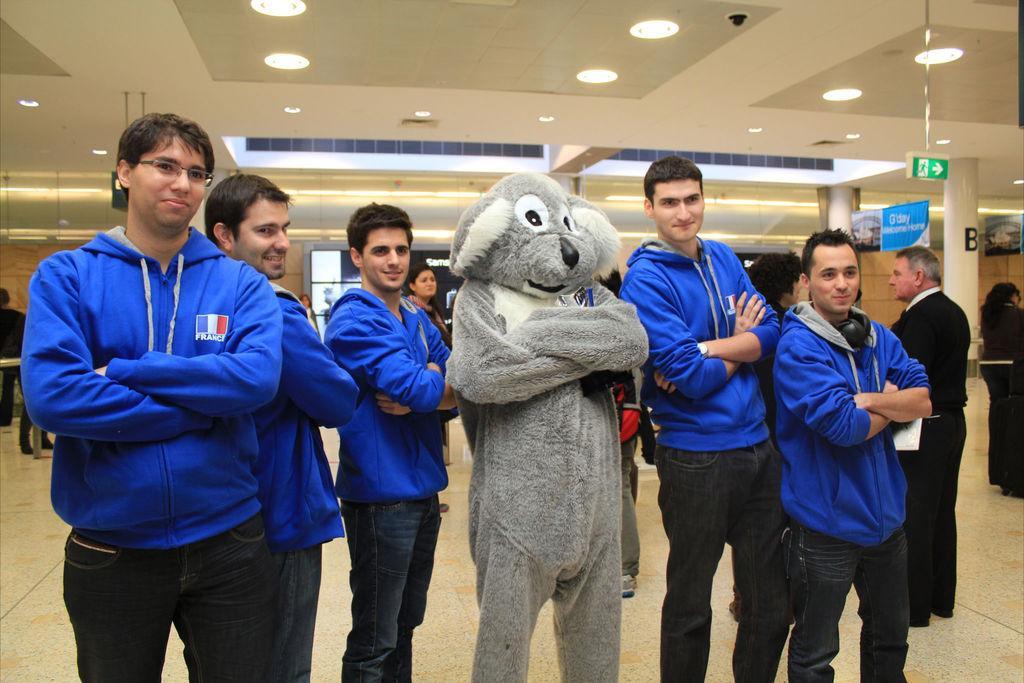Please provide a concise description of this image. Front these people are standing. Background there are people. These are lights. Here we can see banners, pillars and signboards. 